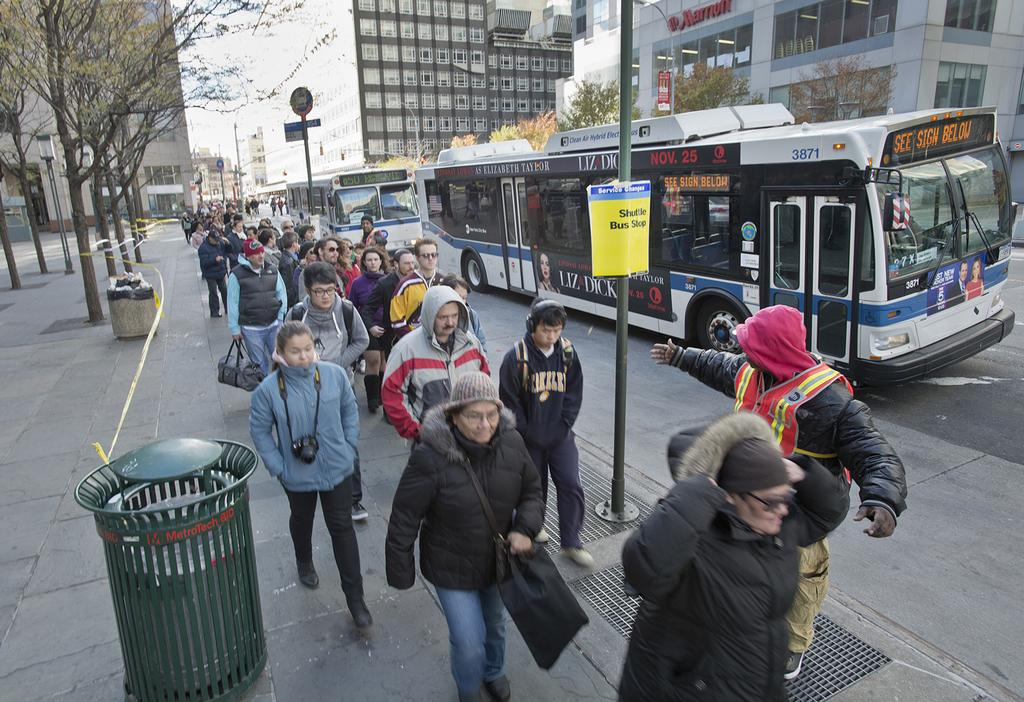What type of vehicles can be seen on the right side of the image? There are buses moving on the road on the right side of the image. What are the people in the image doing? Many people are walking on a footpath in the middle of the image. What type of vegetation is on the left side of the image? There are green trees on the left side of the image. How many fingers can be seen on the trees in the image? There are no fingers present on the trees in the image; they are green trees with leaves. What does society believe about the people walking in the image? The image does not provide any information about what society believes about the people walking; it only shows them walking on a footpath. 